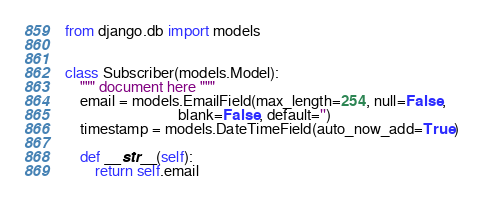Convert code to text. <code><loc_0><loc_0><loc_500><loc_500><_Python_>from django.db import models


class Subscriber(models.Model):
    """ document here """
    email = models.EmailField(max_length=254, null=False,
                              blank=False, default='')
    timestamp = models.DateTimeField(auto_now_add=True)

    def __str__(self):
        return self.email
</code> 